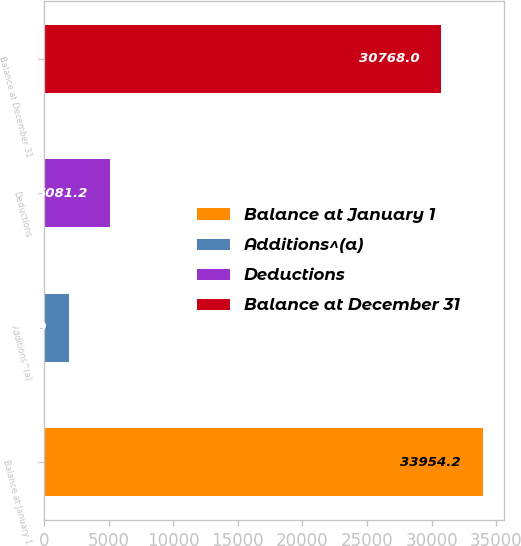Convert chart. <chart><loc_0><loc_0><loc_500><loc_500><bar_chart><fcel>Balance at January 1<fcel>Additions^(a)<fcel>Deductions<fcel>Balance at December 31<nl><fcel>33954.2<fcel>1895<fcel>5081.2<fcel>30768<nl></chart> 